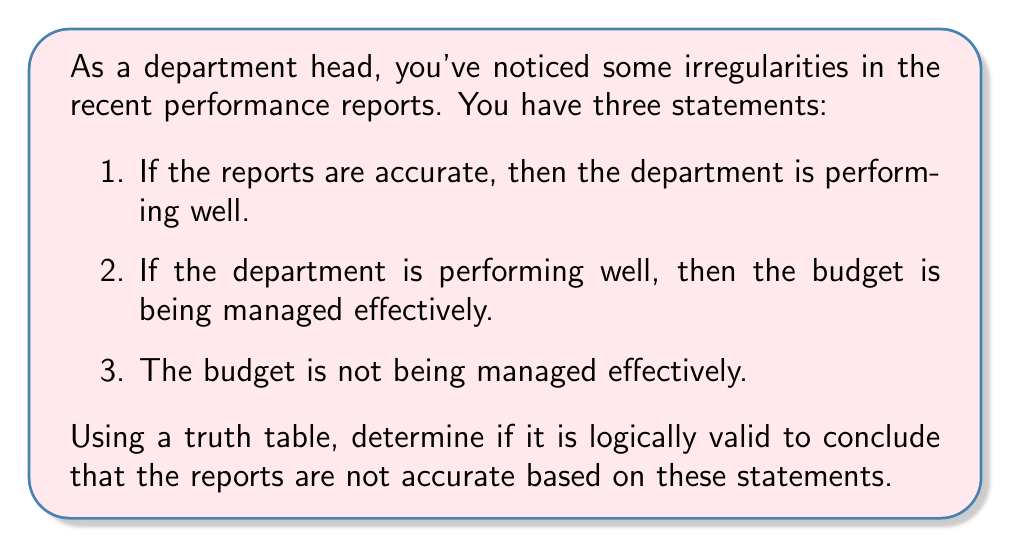Show me your answer to this math problem. Let's approach this step-by-step using a truth table:

1. First, we need to define our propositions:
   $p$: The reports are accurate
   $q$: The department is performing well
   $r$: The budget is being managed effectively

2. Now, we can rewrite our statements using logical connectives:
   Statement 1: $p \rightarrow q$
   Statement 2: $q \rightarrow r$
   Statement 3: $\neg r$

3. We want to check if $\neg p$ (the reports are not accurate) is a valid conclusion from these premises. In logical notation, we're checking the validity of:

   $((p \rightarrow q) \land (q \rightarrow r) \land \neg r) \rightarrow \neg p$

4. Let's create a truth table:

   $$\begin{array}{|c|c|c|c|c|c|c|c|}
   \hline
   p & q & r & p \rightarrow q & q \rightarrow r & \neg r & (p \rightarrow q) \land (q \rightarrow r) \land \neg r & ((p \rightarrow q) \land (q \rightarrow r) \land \neg r) \rightarrow \neg p \\
   \hline
   T & T & T & T & T & F & F & T \\
   T & T & F & T & F & T & F & T \\
   T & F & T & F & T & F & F & T \\
   T & F & F & F & T & T & F & T \\
   F & T & T & T & T & F & F & T \\
   F & T & F & T & F & T & T & T \\
   F & F & T & T & T & F & F & T \\
   F & F & F & T & T & T & T & T \\
   \hline
   \end{array}$$

5. For the conclusion to be logically valid, the last column must be true for all rows. As we can see, this is indeed the case.

Therefore, based on the given statements, it is logically valid to conclude that the reports are not accurate.
Answer: Yes, it is logically valid to conclude that the reports are not accurate based on the given statements. 